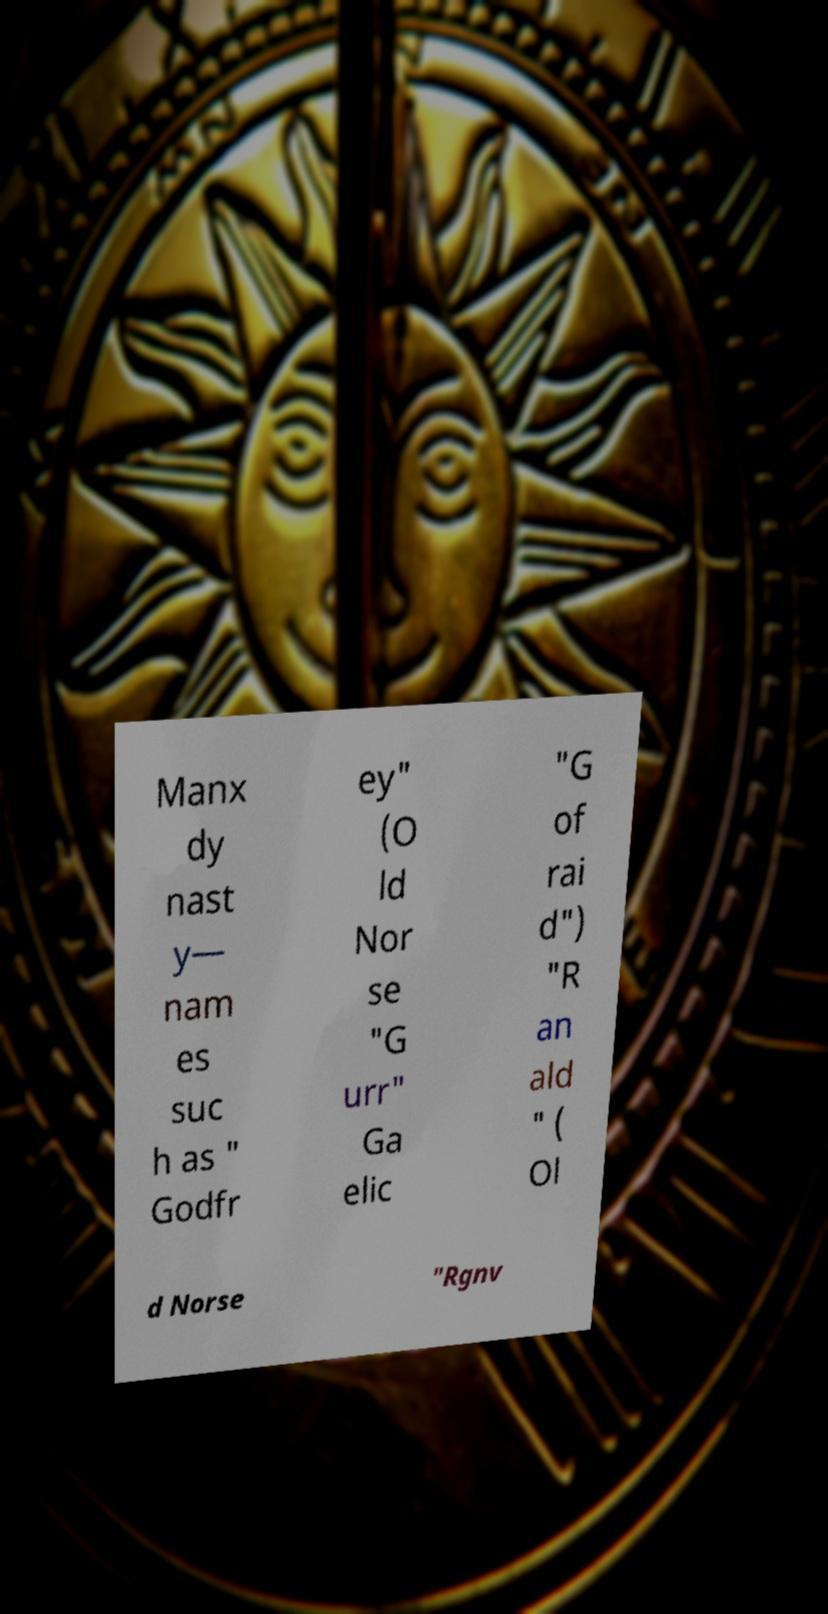Please identify and transcribe the text found in this image. Manx dy nast y— nam es suc h as " Godfr ey" (O ld Nor se "G urr" Ga elic "G of rai d") "R an ald " ( Ol d Norse "Rgnv 